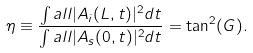<formula> <loc_0><loc_0><loc_500><loc_500>\eta \equiv \frac { \int a l l | A _ { i } ( L , t ) | ^ { 2 } d t } { \int a l l | A _ { s } ( 0 , t ) | ^ { 2 } d t } = \tan ^ { 2 } ( G ) .</formula> 